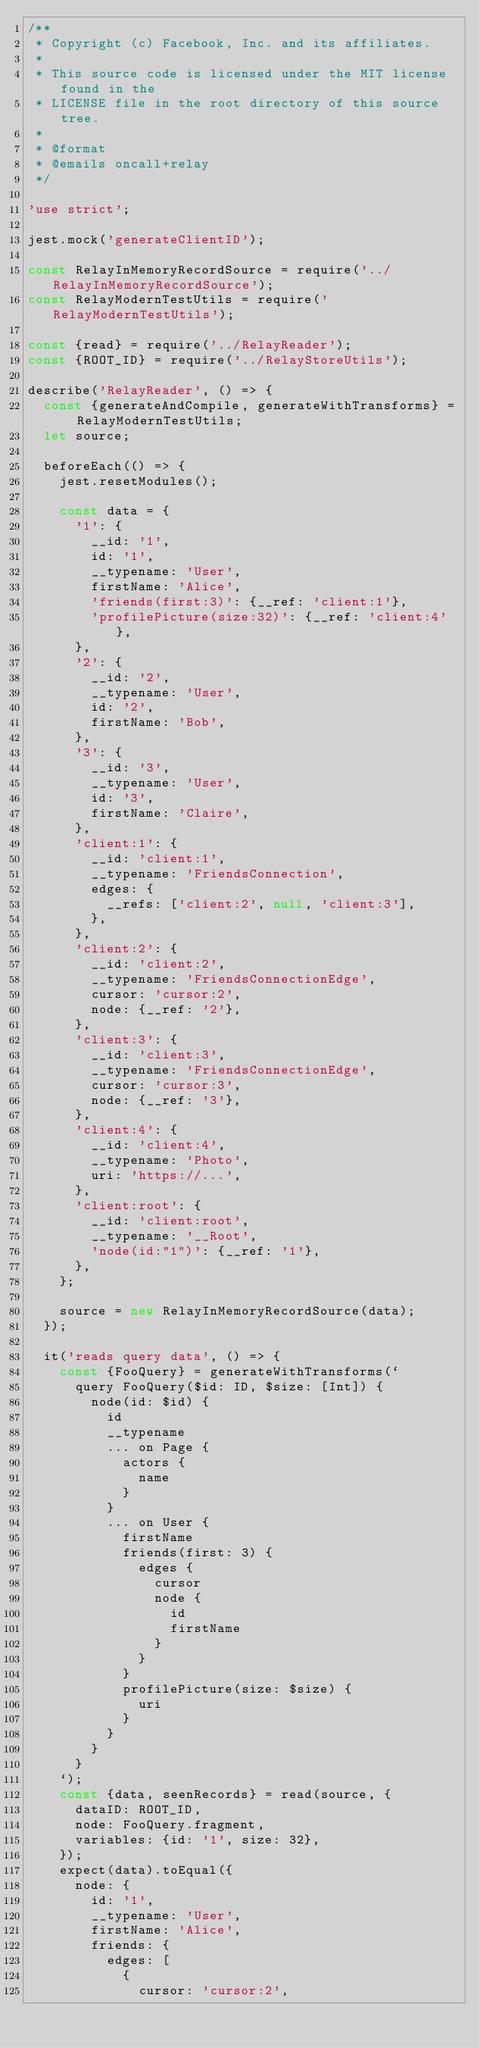<code> <loc_0><loc_0><loc_500><loc_500><_JavaScript_>/**
 * Copyright (c) Facebook, Inc. and its affiliates.
 *
 * This source code is licensed under the MIT license found in the
 * LICENSE file in the root directory of this source tree.
 *
 * @format
 * @emails oncall+relay
 */

'use strict';

jest.mock('generateClientID');

const RelayInMemoryRecordSource = require('../RelayInMemoryRecordSource');
const RelayModernTestUtils = require('RelayModernTestUtils');

const {read} = require('../RelayReader');
const {ROOT_ID} = require('../RelayStoreUtils');

describe('RelayReader', () => {
  const {generateAndCompile, generateWithTransforms} = RelayModernTestUtils;
  let source;

  beforeEach(() => {
    jest.resetModules();

    const data = {
      '1': {
        __id: '1',
        id: '1',
        __typename: 'User',
        firstName: 'Alice',
        'friends(first:3)': {__ref: 'client:1'},
        'profilePicture(size:32)': {__ref: 'client:4'},
      },
      '2': {
        __id: '2',
        __typename: 'User',
        id: '2',
        firstName: 'Bob',
      },
      '3': {
        __id: '3',
        __typename: 'User',
        id: '3',
        firstName: 'Claire',
      },
      'client:1': {
        __id: 'client:1',
        __typename: 'FriendsConnection',
        edges: {
          __refs: ['client:2', null, 'client:3'],
        },
      },
      'client:2': {
        __id: 'client:2',
        __typename: 'FriendsConnectionEdge',
        cursor: 'cursor:2',
        node: {__ref: '2'},
      },
      'client:3': {
        __id: 'client:3',
        __typename: 'FriendsConnectionEdge',
        cursor: 'cursor:3',
        node: {__ref: '3'},
      },
      'client:4': {
        __id: 'client:4',
        __typename: 'Photo',
        uri: 'https://...',
      },
      'client:root': {
        __id: 'client:root',
        __typename: '__Root',
        'node(id:"1")': {__ref: '1'},
      },
    };

    source = new RelayInMemoryRecordSource(data);
  });

  it('reads query data', () => {
    const {FooQuery} = generateWithTransforms(`
      query FooQuery($id: ID, $size: [Int]) {
        node(id: $id) {
          id
          __typename
          ... on Page {
            actors {
              name
            }
          }
          ... on User {
            firstName
            friends(first: 3) {
              edges {
                cursor
                node {
                  id
                  firstName
                }
              }
            }
            profilePicture(size: $size) {
              uri
            }
          }
        }
      }
    `);
    const {data, seenRecords} = read(source, {
      dataID: ROOT_ID,
      node: FooQuery.fragment,
      variables: {id: '1', size: 32},
    });
    expect(data).toEqual({
      node: {
        id: '1',
        __typename: 'User',
        firstName: 'Alice',
        friends: {
          edges: [
            {
              cursor: 'cursor:2',</code> 